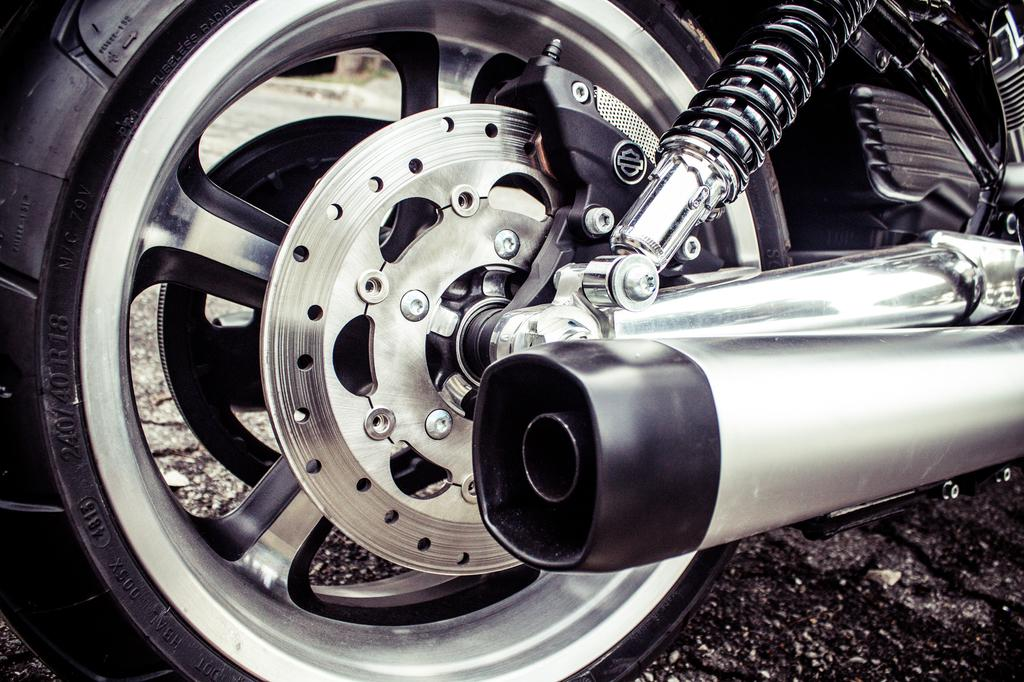What is the main subject of the image? There is a bike in the image. What type of help can be seen being offered at the market in the image? There is no market or help being offered in the image; it only features a bike. 